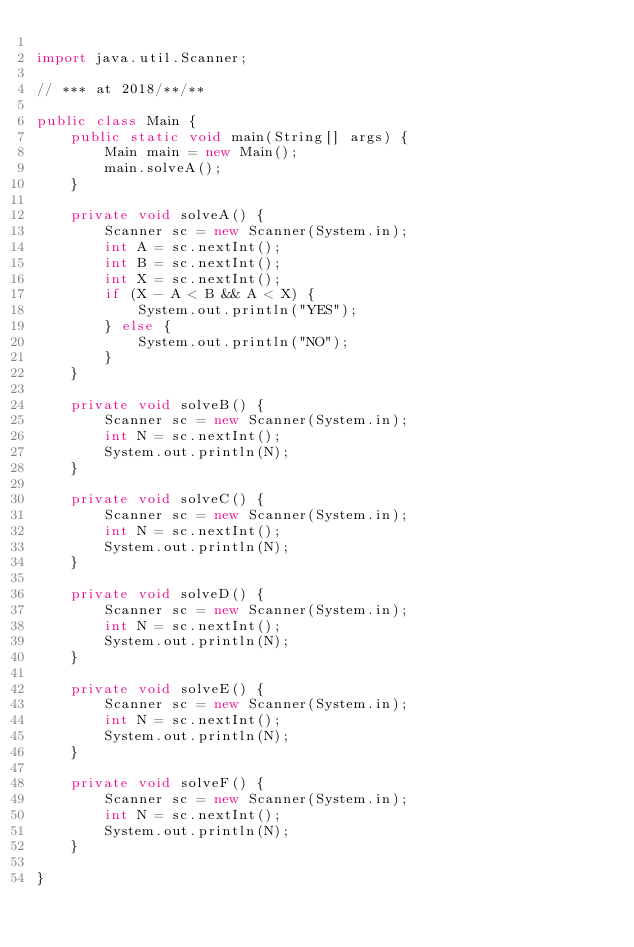Convert code to text. <code><loc_0><loc_0><loc_500><loc_500><_Java_>
import java.util.Scanner;

// *** at 2018/**/**

public class Main {
    public static void main(String[] args) {
        Main main = new Main();
        main.solveA();
    }

    private void solveA() {
        Scanner sc = new Scanner(System.in);
        int A = sc.nextInt();
        int B = sc.nextInt();
        int X = sc.nextInt();
        if (X - A < B && A < X) {
            System.out.println("YES");
        } else {
        	System.out.println("NO");
        }
    }

    private void solveB() {
        Scanner sc = new Scanner(System.in);
        int N = sc.nextInt();
        System.out.println(N);
    }

    private void solveC() {
        Scanner sc = new Scanner(System.in);
        int N = sc.nextInt();
        System.out.println(N);
    }

    private void solveD() {
        Scanner sc = new Scanner(System.in);
        int N = sc.nextInt();
        System.out.println(N);
    }

    private void solveE() {
        Scanner sc = new Scanner(System.in);
        int N = sc.nextInt();
        System.out.println(N);
    }

    private void solveF() {
        Scanner sc = new Scanner(System.in);
        int N = sc.nextInt();
        System.out.println(N);
    }

}</code> 